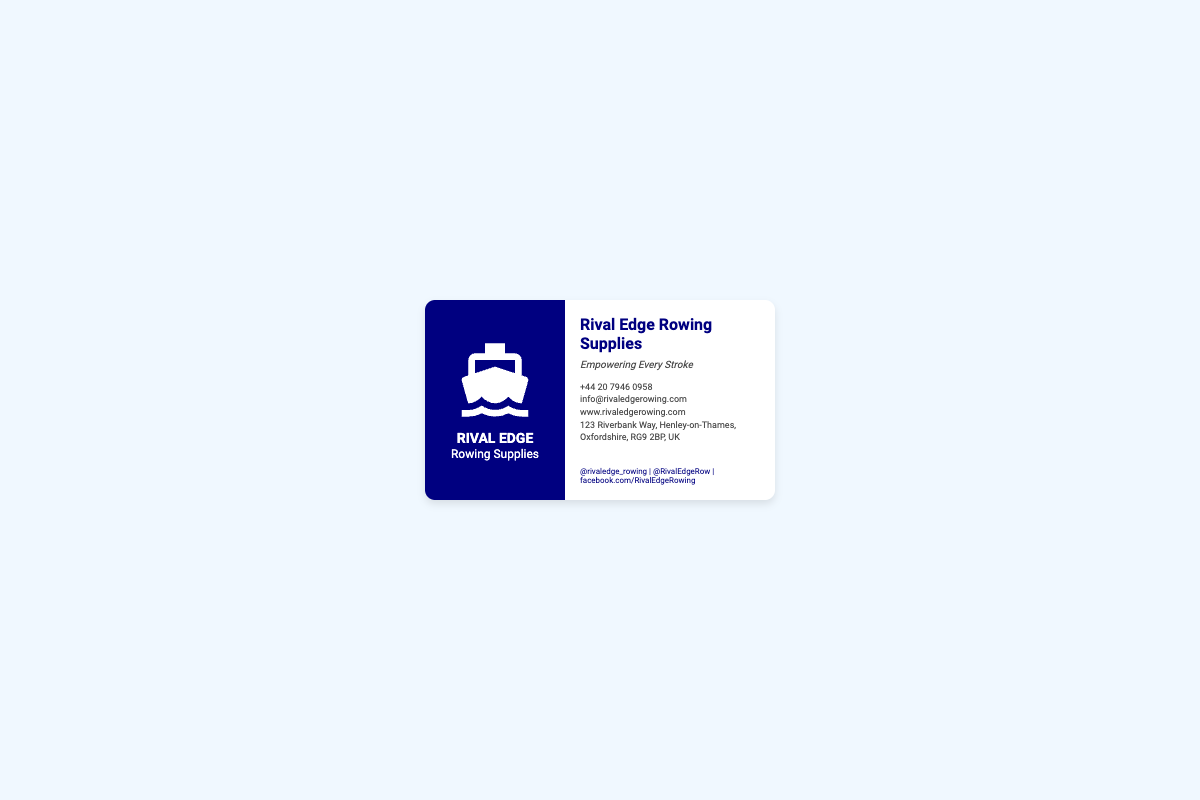What is the company name? The company name is prominently displayed on the business card.
Answer: Rival Edge Rowing Supplies What is the contact phone number? The phone number is listed under the contact info section.
Answer: +44 20 7946 0958 What is the tagline of the company? The tagline beneath the company name indicates the company's philosophy.
Answer: Empowering Every Stroke What is the website URL? The website is provided in the contact information section.
Answer: www.rivaledgerowing.com Where is the company located? The address is given in the contact information section.
Answer: 123 Riverbank Way, Henley-on-Thames, Oxfordshire, RG9 2BP, UK What social media handle is listed first? The first handle in the social media section indicates their Twitter handle.
Answer: @rivaledge_rowing How many sides does the business card have? The document describes a two-sided layout of the card.
Answer: Two What graphic is featured on the left side of the card? The graphic represents the business's identity related to rowing.
Answer: Rowing boat graphic What color scheme is predominantly used on the left side? Observing the left section reveals the primary background color.
Answer: Dark blue What is the size of the business card? The dimensions are specified in the card's design details.
Answer: 350px by 200px 